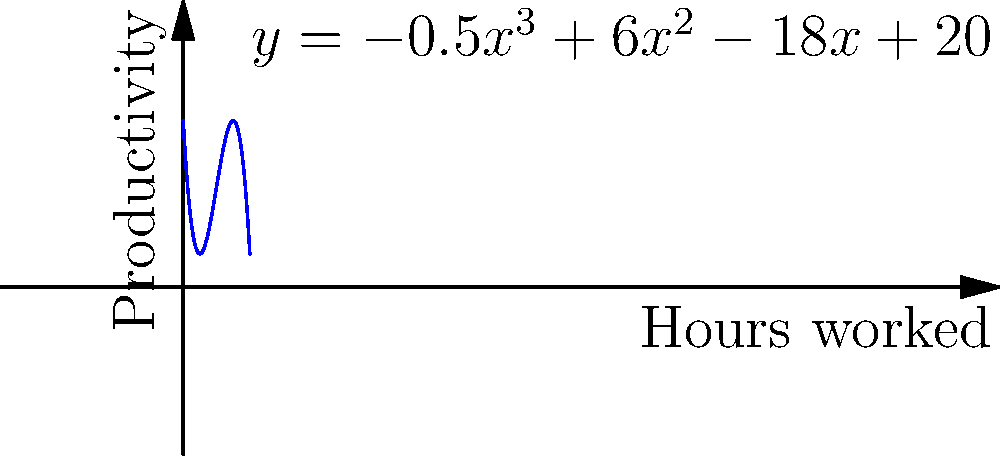As a project manager for an ERP implementation, you're tasked with optimizing resource allocation. The productivity of your team is modeled by the cubic function $y=-0.5x^3+6x^2-18x+20$, where $y$ represents productivity and $x$ represents hours worked per day. What is the optimal number of hours your team should work to maximize productivity? To find the optimal number of hours that maximize productivity, we need to follow these steps:

1. The function given is $y=-0.5x^3+6x^2-18x+20$

2. To find the maximum, we need to find where the derivative of this function equals zero.

3. The derivative is:
   $$\frac{dy}{dx} = -1.5x^2 + 12x - 18$$

4. Set this equal to zero:
   $$-1.5x^2 + 12x - 18 = 0$$

5. This is a quadratic equation. We can solve it using the quadratic formula:
   $$x = \frac{-b \pm \sqrt{b^2 - 4ac}}{2a}$$
   where $a=-1.5$, $b=12$, and $c=-18$

6. Plugging in these values:
   $$x = \frac{-12 \pm \sqrt{12^2 - 4(-1.5)(-18)}}{2(-1.5)}$$

7. Simplifying:
   $$x = \frac{-12 \pm \sqrt{144 - 108}}{-3} = \frac{-12 \pm \sqrt{36}}{-3} = \frac{-12 \pm 6}{-3}$$

8. This gives us two solutions:
   $$x = \frac{-12 + 6}{-3} = 2$$ or $$x = \frac{-12 - 6}{-3} = 6$$

9. To determine which of these is the maximum (rather than the minimum), we can check the second derivative:
   $$\frac{d^2y}{dx^2} = -3x + 12$$

10. At $x=2$: $-3(2) + 12 = 6$ (positive, so this is a minimum)
    At $x=6$: $-3(6) + 12 = -6$ (negative, so this is a maximum)

Therefore, productivity is maximized when the team works 6 hours per day.
Answer: 6 hours 